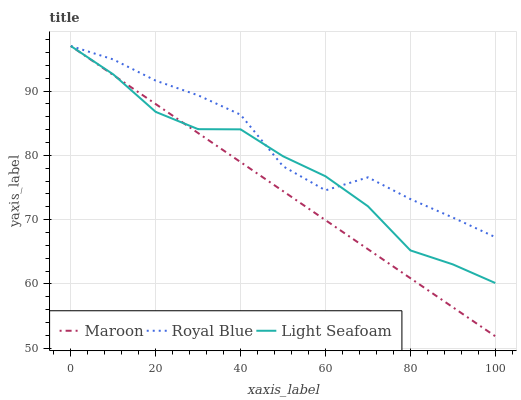Does Maroon have the minimum area under the curve?
Answer yes or no. Yes. Does Royal Blue have the maximum area under the curve?
Answer yes or no. Yes. Does Light Seafoam have the minimum area under the curve?
Answer yes or no. No. Does Light Seafoam have the maximum area under the curve?
Answer yes or no. No. Is Maroon the smoothest?
Answer yes or no. Yes. Is Royal Blue the roughest?
Answer yes or no. Yes. Is Light Seafoam the smoothest?
Answer yes or no. No. Is Light Seafoam the roughest?
Answer yes or no. No. Does Light Seafoam have the lowest value?
Answer yes or no. No. Does Maroon have the highest value?
Answer yes or no. Yes. 